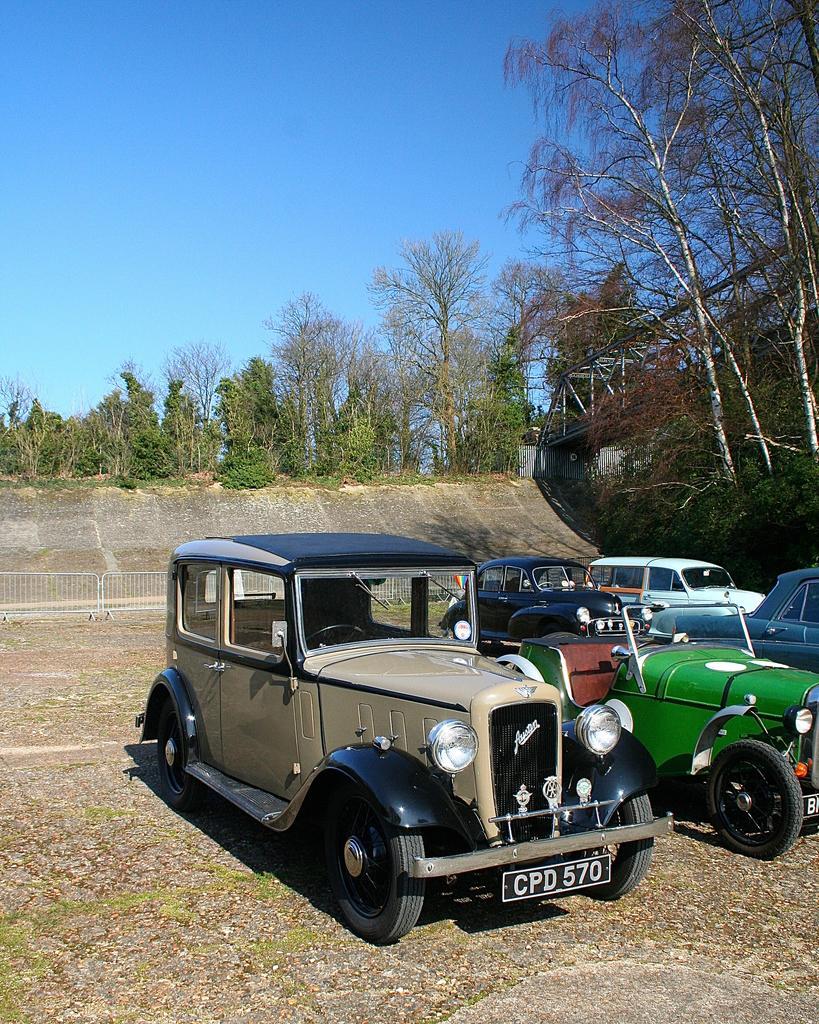Can you describe this image briefly? This image consists of many cars parked on the ground. It looks like old vintage cars. At the bottom, there is a ground. In the background, there are many trees. At the top, there is a sky. On the right, we can see a bridge. Behind the cars, there is a fencing. 